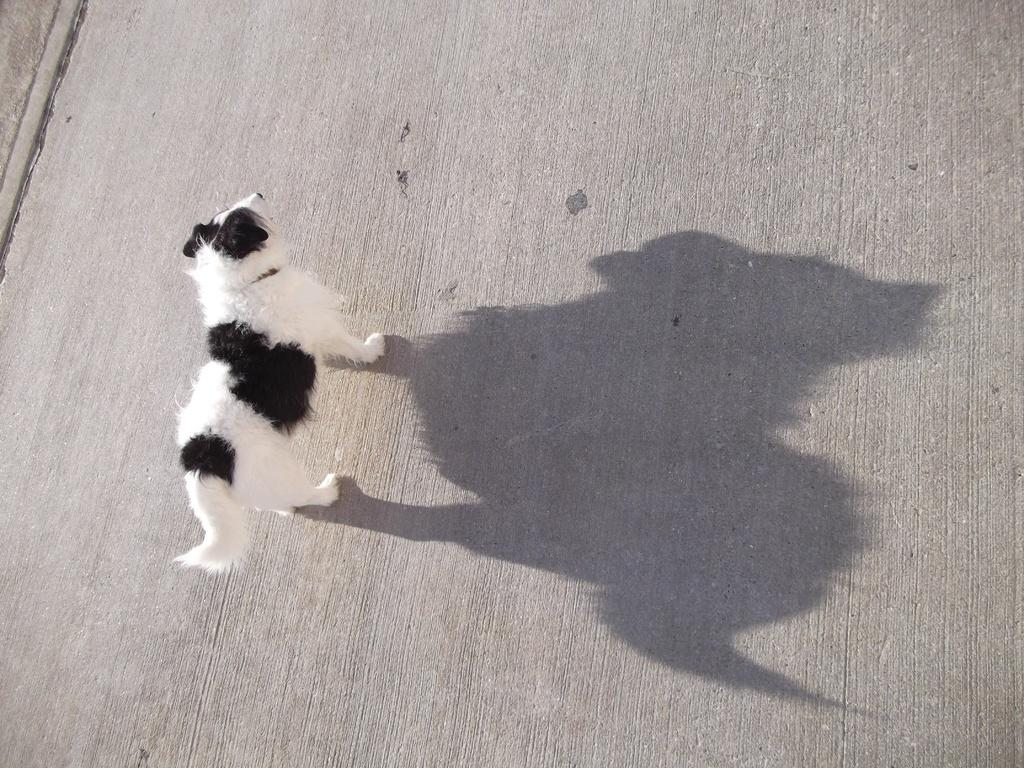What type of animal is in the image? There is a dog in the image. What is the dog doing in the image? The dog is standing. Where is the dog's shadow located in the image? The dog's shadow is on the road. What direction is the amusement park located in the image? There is no amusement park present in the image. Is there a zipper on the dog's collar in the image? The image does not show the dog's collar, so it cannot be determined if there is a zipper on it. 